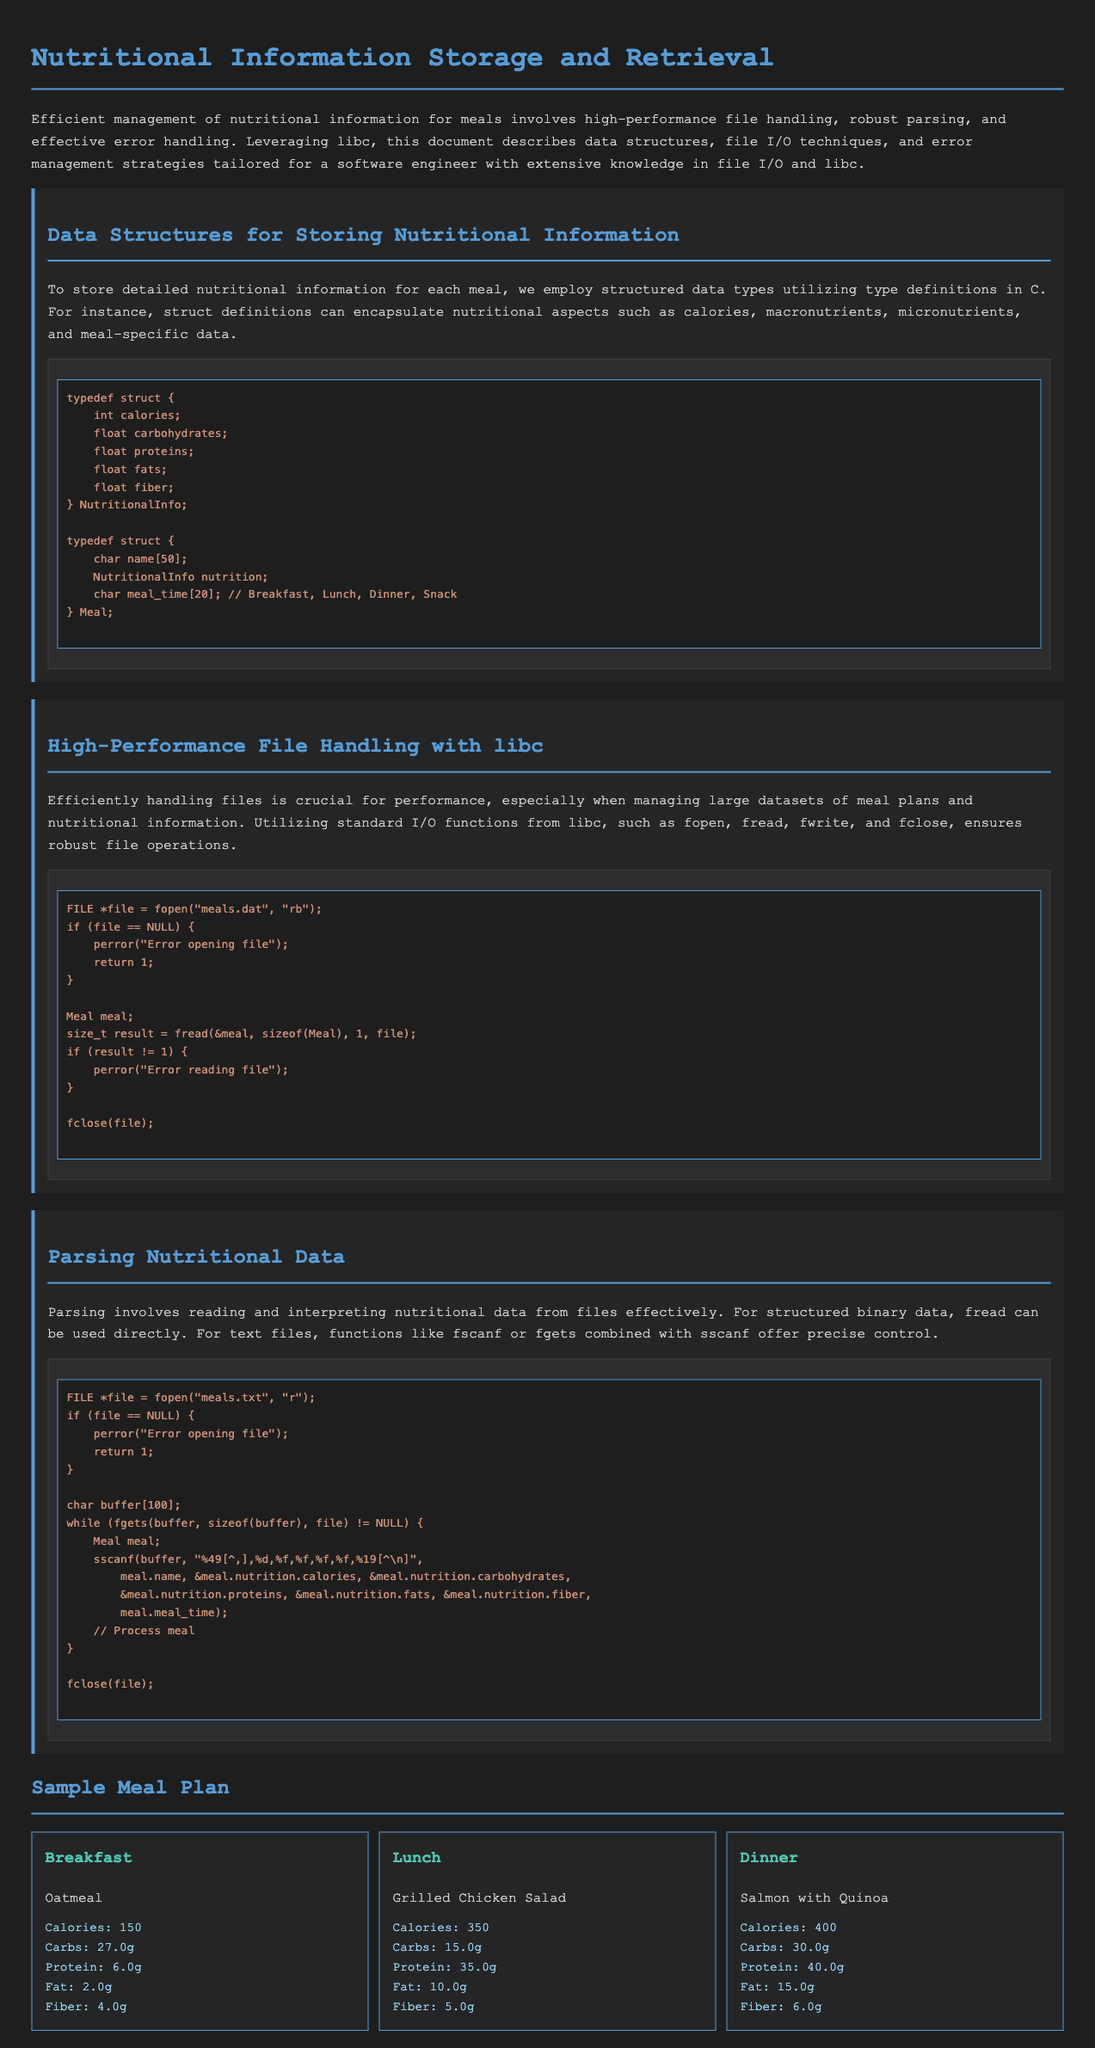what is the primary focus of the document? The document focuses on managing nutritional information for meals through file handling, parsing, and error handling.
Answer: Nutritional information storage and retrieval how many meals are presented in the sample meal plan? The document lists three meals: Breakfast, Lunch, and Dinner.
Answer: Three what is the name of the breakfast meal? The breakfast meal specified in the document is Oatmeal.
Answer: Oatmeal how many grams of carbohydrates are in the lunch meal? The lunch meal contains 15.0 grams of carbohydrates as indicated in the nutrition info.
Answer: 15.0g what function is used to open a binary file? The function mentioned for opening a binary file is fopen.
Answer: fopen which macronutrient has the highest value in the dinner meal? The dinner meal has the highest protein value of 40.0g as indicated in the nutrition info.
Answer: Protein what is the typical data structure used for storing nutritional information? The document utilizes structured data types defined by struct in C for nutritional information.
Answer: struct how is error handling performed when opening a file? The document demonstrates error handling by checking if the file pointer is NULL after calling fopen.
Answer: Checking if NULL what is the meal time associated with the "Grilled Chicken Salad"? The meal time for the "Grilled Chicken Salad" meal is Lunch.
Answer: Lunch 